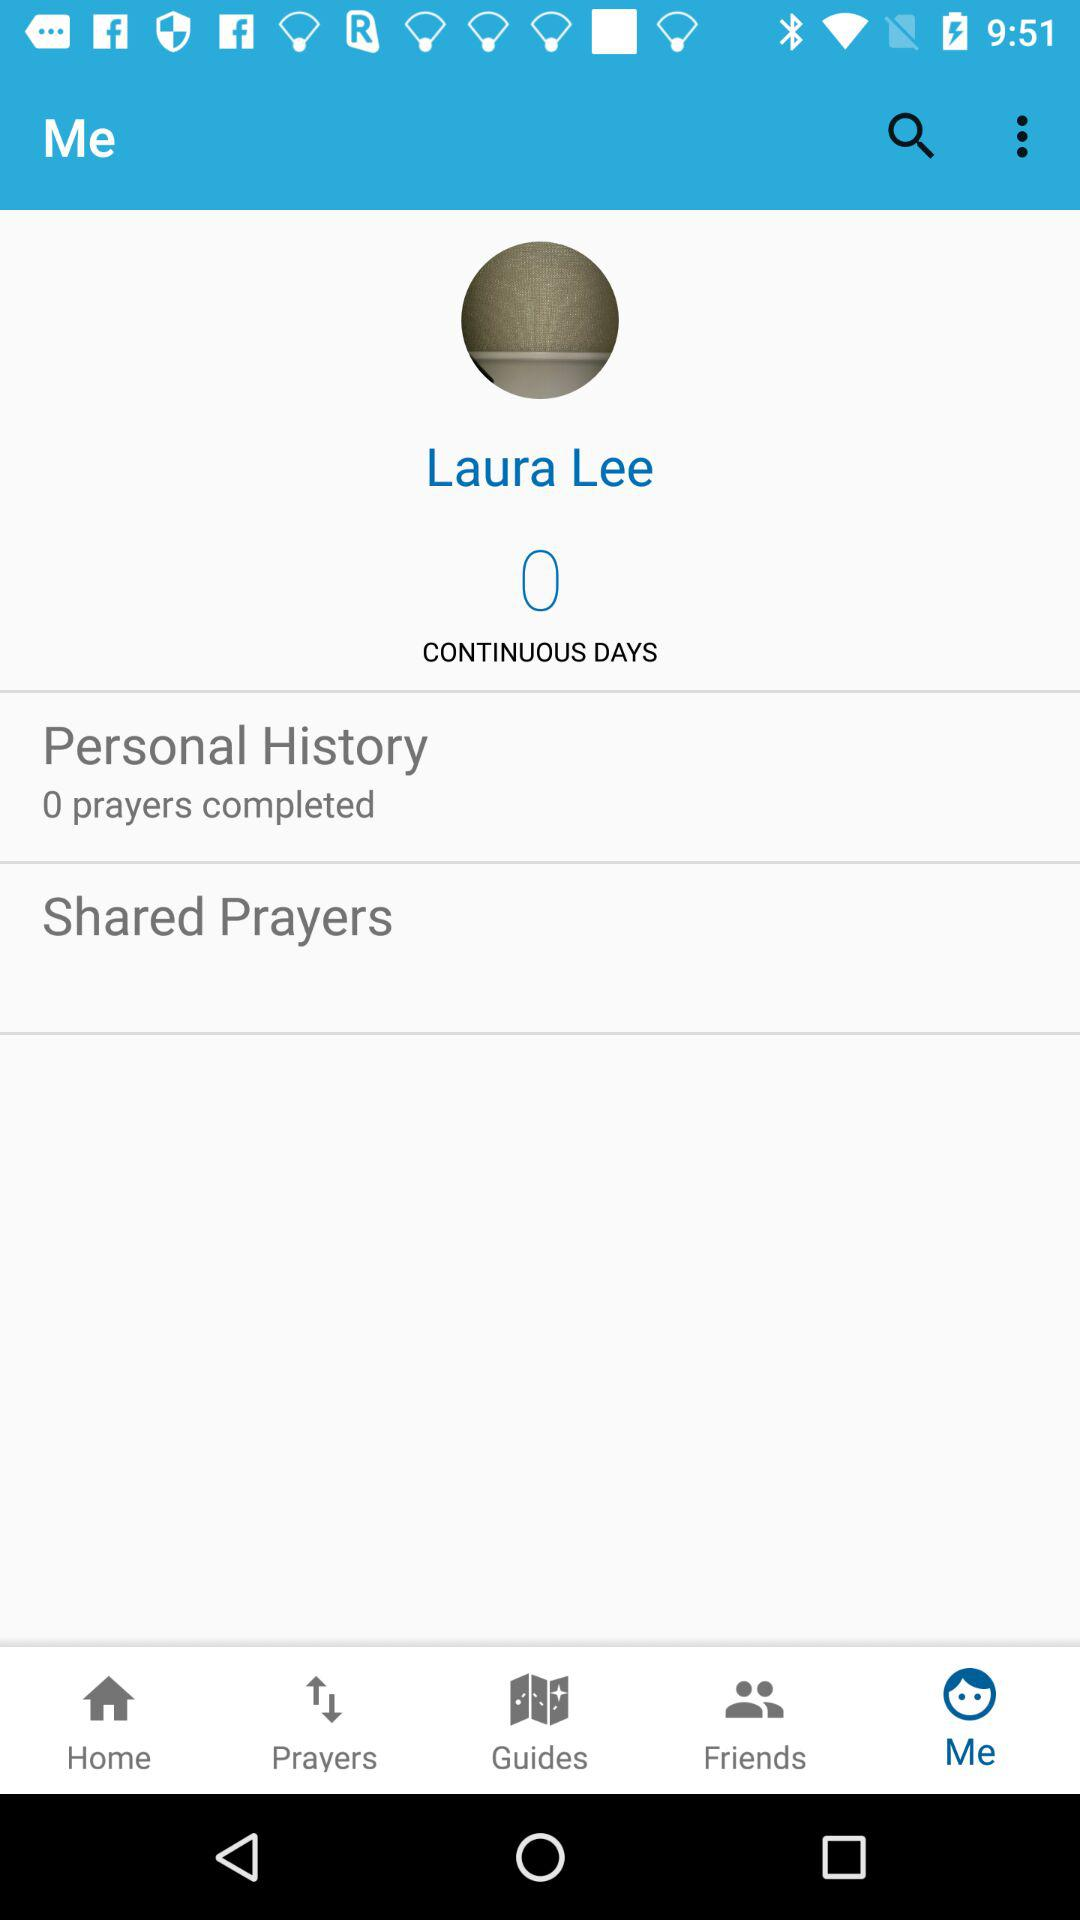What is the name? The name is Laura Lee. 